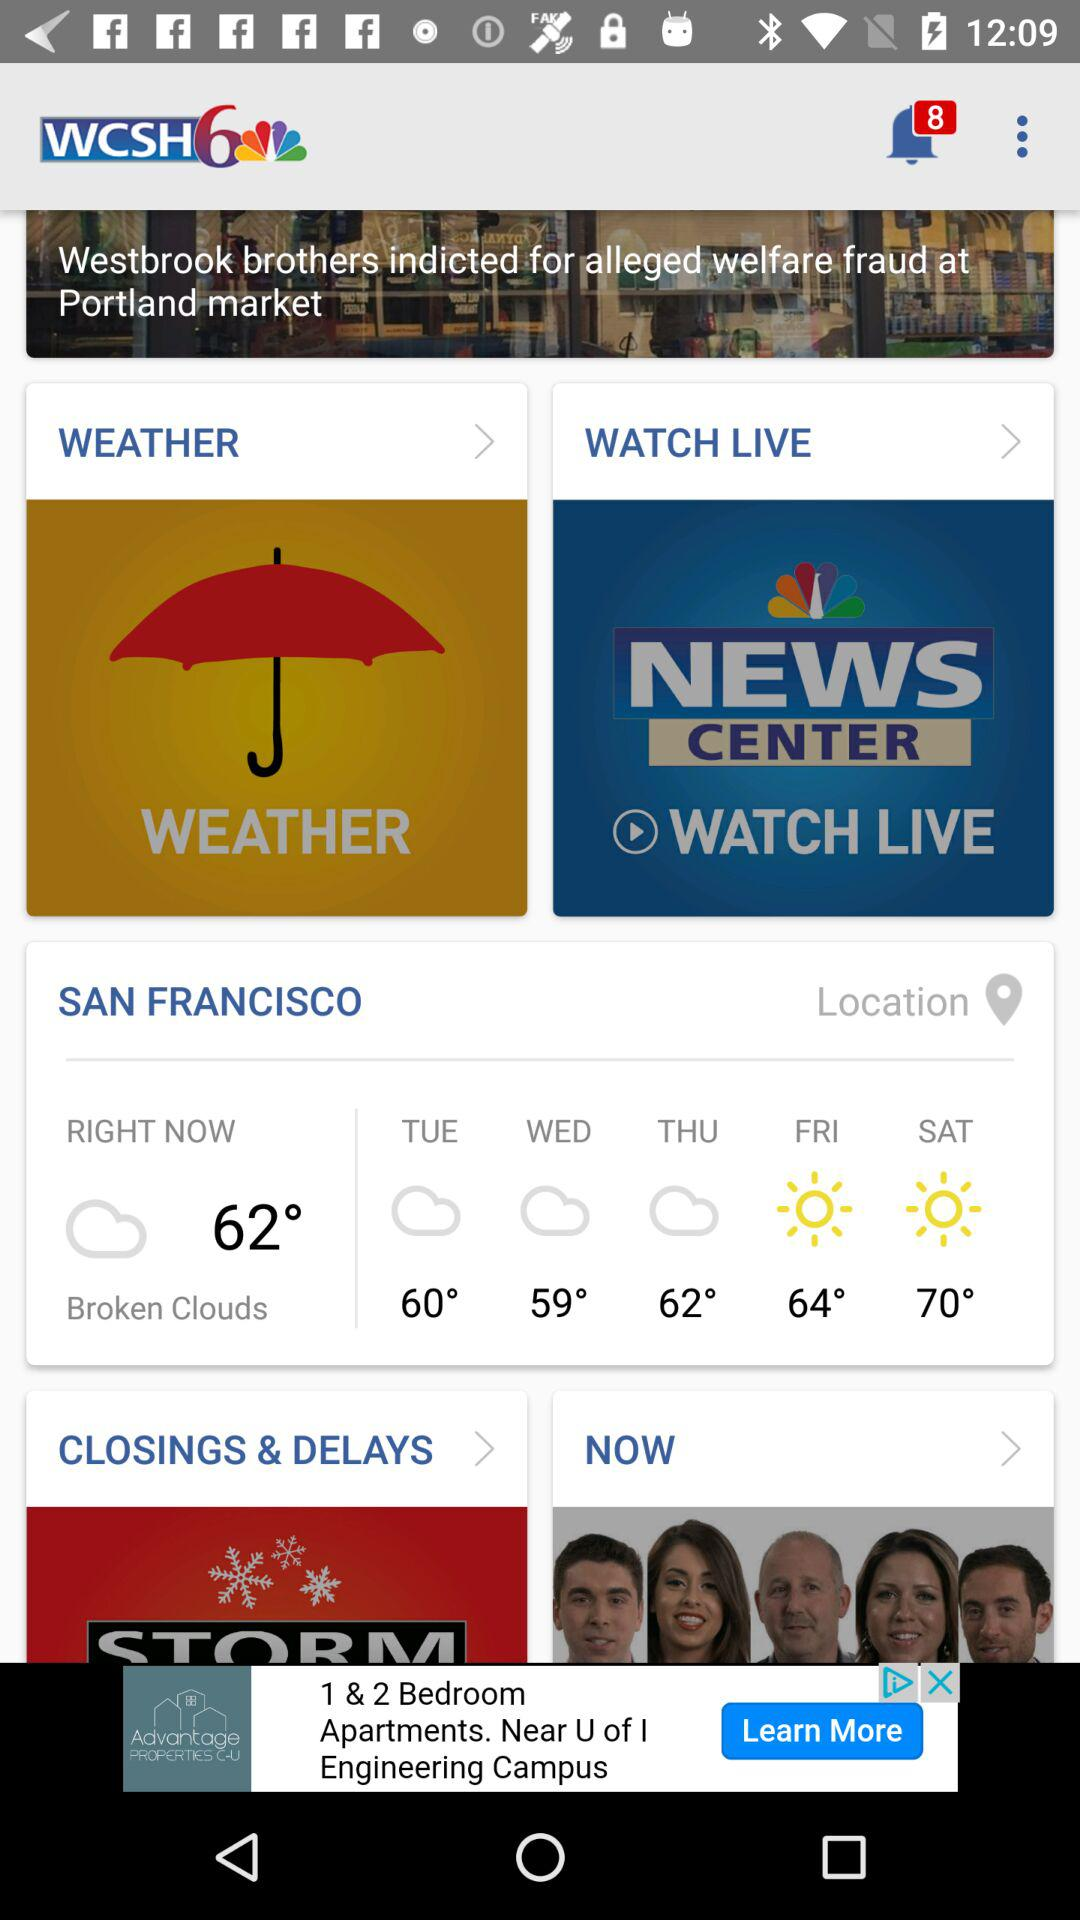What is the weather like in San Francisco? The weather in San Francisco is "Broken Clouds". 